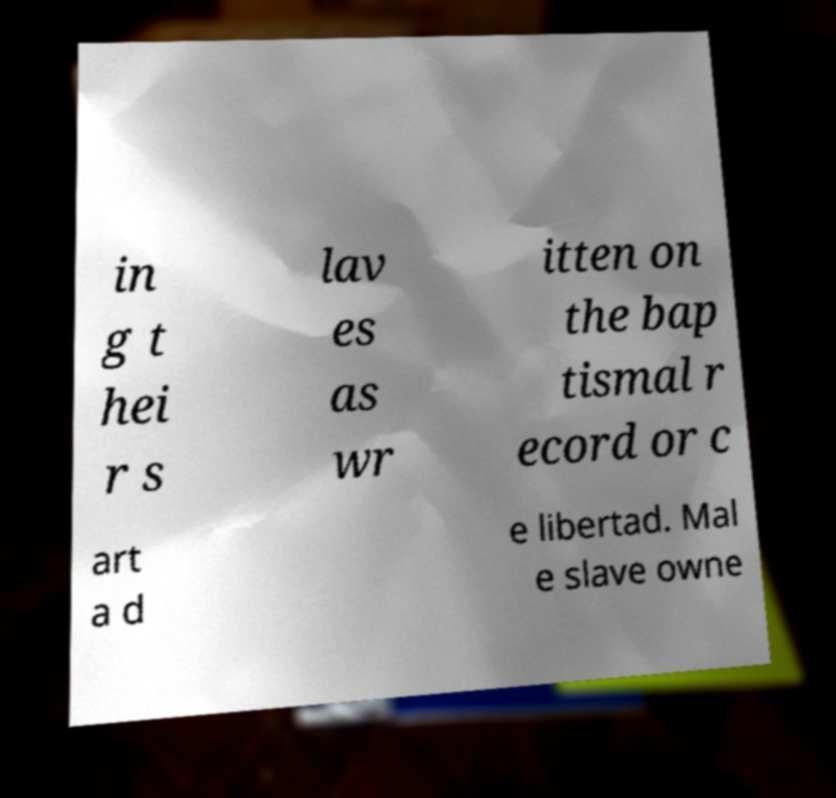Could you extract and type out the text from this image? in g t hei r s lav es as wr itten on the bap tismal r ecord or c art a d e libertad. Mal e slave owne 